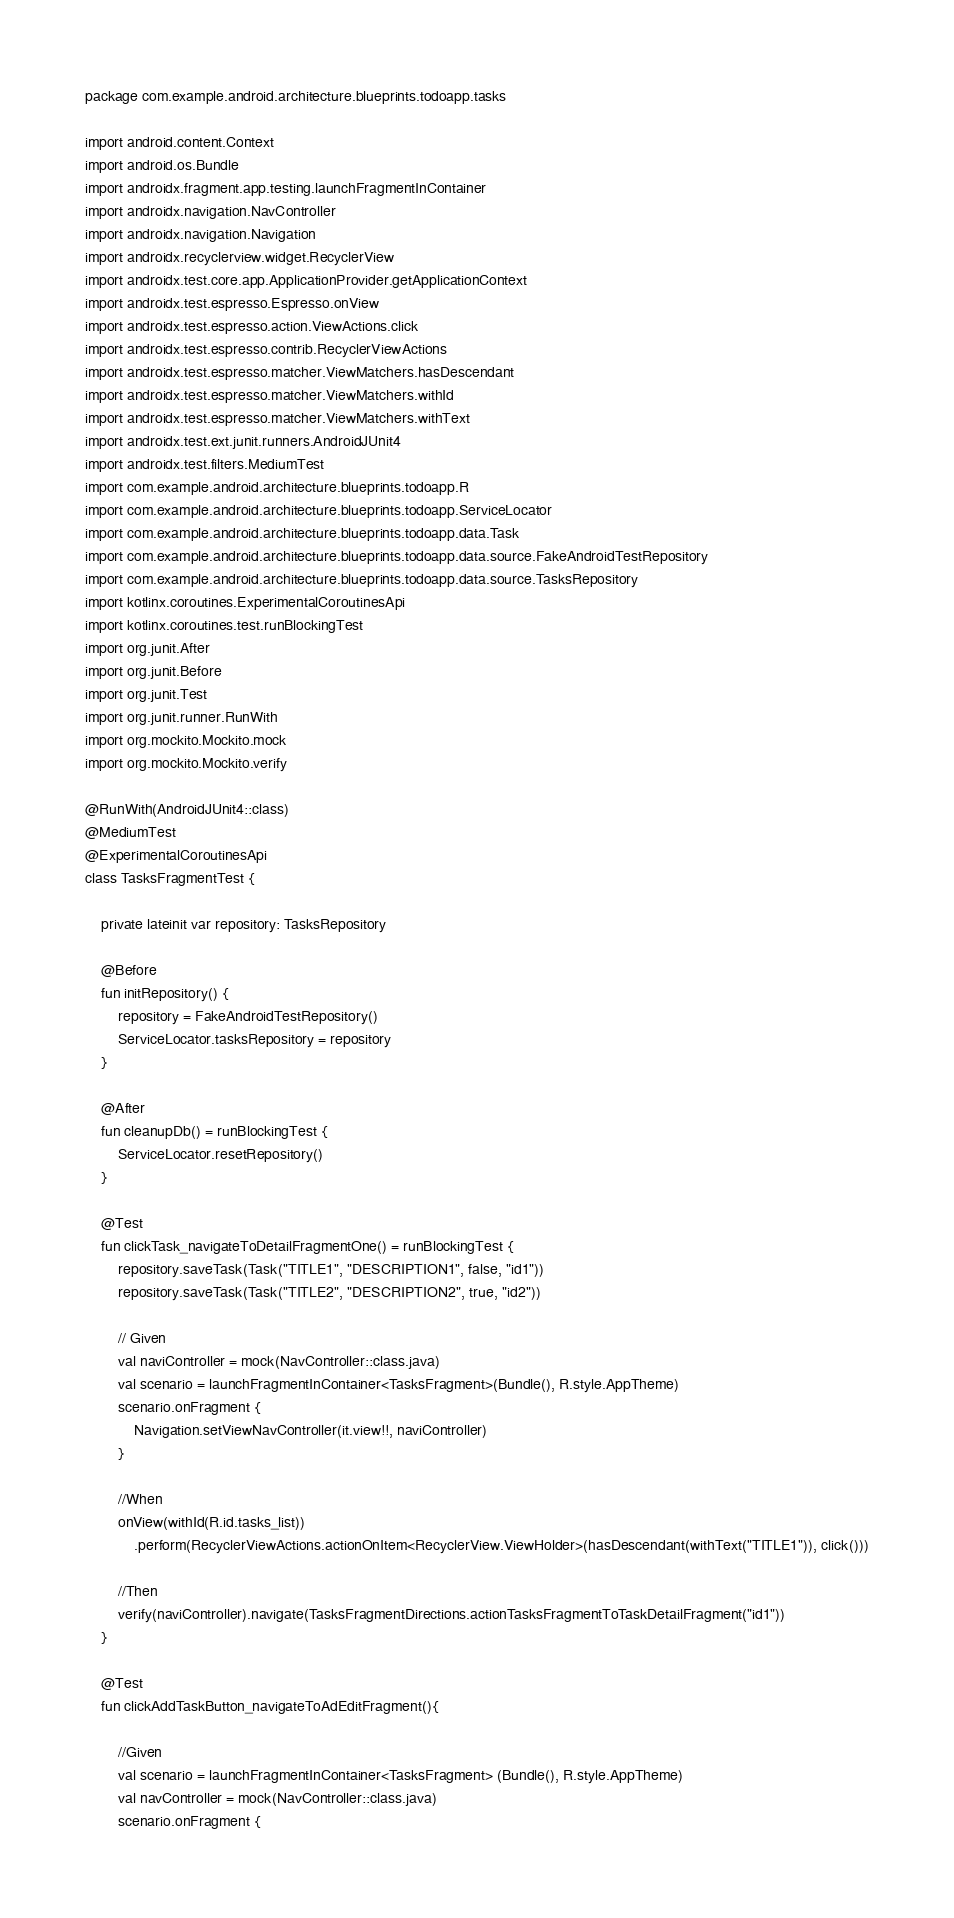<code> <loc_0><loc_0><loc_500><loc_500><_Kotlin_>package com.example.android.architecture.blueprints.todoapp.tasks

import android.content.Context
import android.os.Bundle
import androidx.fragment.app.testing.launchFragmentInContainer
import androidx.navigation.NavController
import androidx.navigation.Navigation
import androidx.recyclerview.widget.RecyclerView
import androidx.test.core.app.ApplicationProvider.getApplicationContext
import androidx.test.espresso.Espresso.onView
import androidx.test.espresso.action.ViewActions.click
import androidx.test.espresso.contrib.RecyclerViewActions
import androidx.test.espresso.matcher.ViewMatchers.hasDescendant
import androidx.test.espresso.matcher.ViewMatchers.withId
import androidx.test.espresso.matcher.ViewMatchers.withText
import androidx.test.ext.junit.runners.AndroidJUnit4
import androidx.test.filters.MediumTest
import com.example.android.architecture.blueprints.todoapp.R
import com.example.android.architecture.blueprints.todoapp.ServiceLocator
import com.example.android.architecture.blueprints.todoapp.data.Task
import com.example.android.architecture.blueprints.todoapp.data.source.FakeAndroidTestRepository
import com.example.android.architecture.blueprints.todoapp.data.source.TasksRepository
import kotlinx.coroutines.ExperimentalCoroutinesApi
import kotlinx.coroutines.test.runBlockingTest
import org.junit.After
import org.junit.Before
import org.junit.Test
import org.junit.runner.RunWith
import org.mockito.Mockito.mock
import org.mockito.Mockito.verify

@RunWith(AndroidJUnit4::class)
@MediumTest
@ExperimentalCoroutinesApi
class TasksFragmentTest {

    private lateinit var repository: TasksRepository

    @Before
    fun initRepository() {
        repository = FakeAndroidTestRepository()
        ServiceLocator.tasksRepository = repository
    }

    @After
    fun cleanupDb() = runBlockingTest {
        ServiceLocator.resetRepository()
    }

    @Test
    fun clickTask_navigateToDetailFragmentOne() = runBlockingTest {
        repository.saveTask(Task("TITLE1", "DESCRIPTION1", false, "id1"))
        repository.saveTask(Task("TITLE2", "DESCRIPTION2", true, "id2"))

        // Given
        val naviController = mock(NavController::class.java)
        val scenario = launchFragmentInContainer<TasksFragment>(Bundle(), R.style.AppTheme)
        scenario.onFragment {
            Navigation.setViewNavController(it.view!!, naviController)
        }

        //When
        onView(withId(R.id.tasks_list))
            .perform(RecyclerViewActions.actionOnItem<RecyclerView.ViewHolder>(hasDescendant(withText("TITLE1")), click()))

        //Then
        verify(naviController).navigate(TasksFragmentDirections.actionTasksFragmentToTaskDetailFragment("id1"))
    }

    @Test
    fun clickAddTaskButton_navigateToAdEditFragment(){

        //Given
        val scenario = launchFragmentInContainer<TasksFragment> (Bundle(), R.style.AppTheme)
        val navController = mock(NavController::class.java)
        scenario.onFragment {</code> 